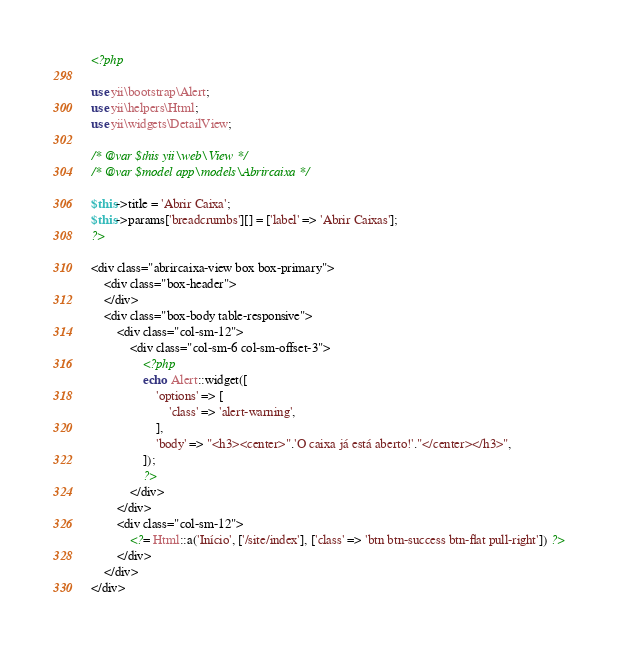<code> <loc_0><loc_0><loc_500><loc_500><_PHP_><?php

use yii\bootstrap\Alert;
use yii\helpers\Html;
use yii\widgets\DetailView;

/* @var $this yii\web\View */
/* @var $model app\models\Abrircaixa */

$this->title = 'Abrir Caixa';
$this->params['breadcrumbs'][] = ['label' => 'Abrir Caixas'];
?>

<div class="abrircaixa-view box box-primary">
    <div class="box-header">
    </div>
    <div class="box-body table-responsive">
        <div class="col-sm-12">
            <div class="col-sm-6 col-sm-offset-3">
                <?php
                echo Alert::widget([
                    'options' => [
                        'class' => 'alert-warning',
                    ],
                    'body' => "<h3><center>".'O caixa já está aberto!'."</center></h3>",
                ]);
                ?>
            </div>
        </div>
        <div class="col-sm-12">
            <?= Html::a('Início', ['/site/index'], ['class' => 'btn btn-success btn-flat pull-right']) ?>
        </div>
    </div>
</div>
</code> 